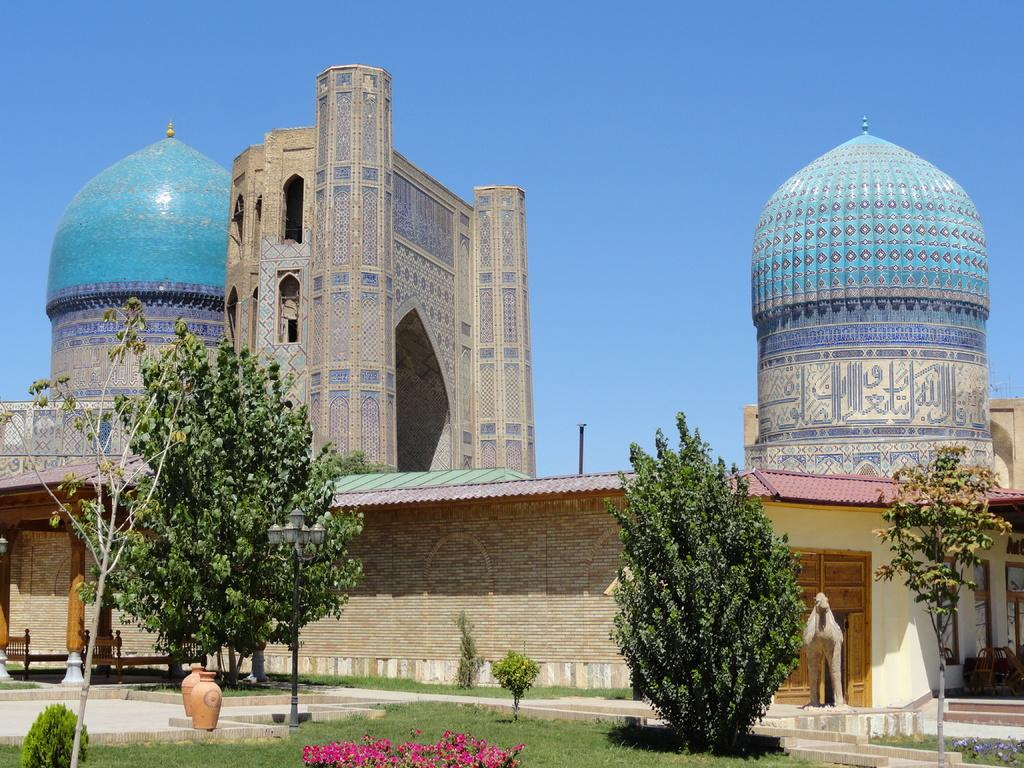What type of building is in the image? There is a mosque in the image. What type of vegetation can be seen in the image? There are trees and plants in the image. What type of decorative objects are in the image? There are vases in the image. What type of furniture is in the image? There are cots in the image. What type of artwork is in the image? There is a sculpture of an animal in the image. What is visible in the background of the image? The sky is visible in the background of the image. What type of quartz is used as a decorative element in the image? There is no quartz present in the image. What time is displayed on the clock in the image? There is no clock present in the image. 